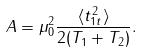<formula> <loc_0><loc_0><loc_500><loc_500>A = \mu _ { 0 } ^ { 2 } \frac { \langle t _ { 1 t } ^ { 2 } \rangle } { 2 ( T _ { 1 } + T _ { 2 } ) } .</formula> 